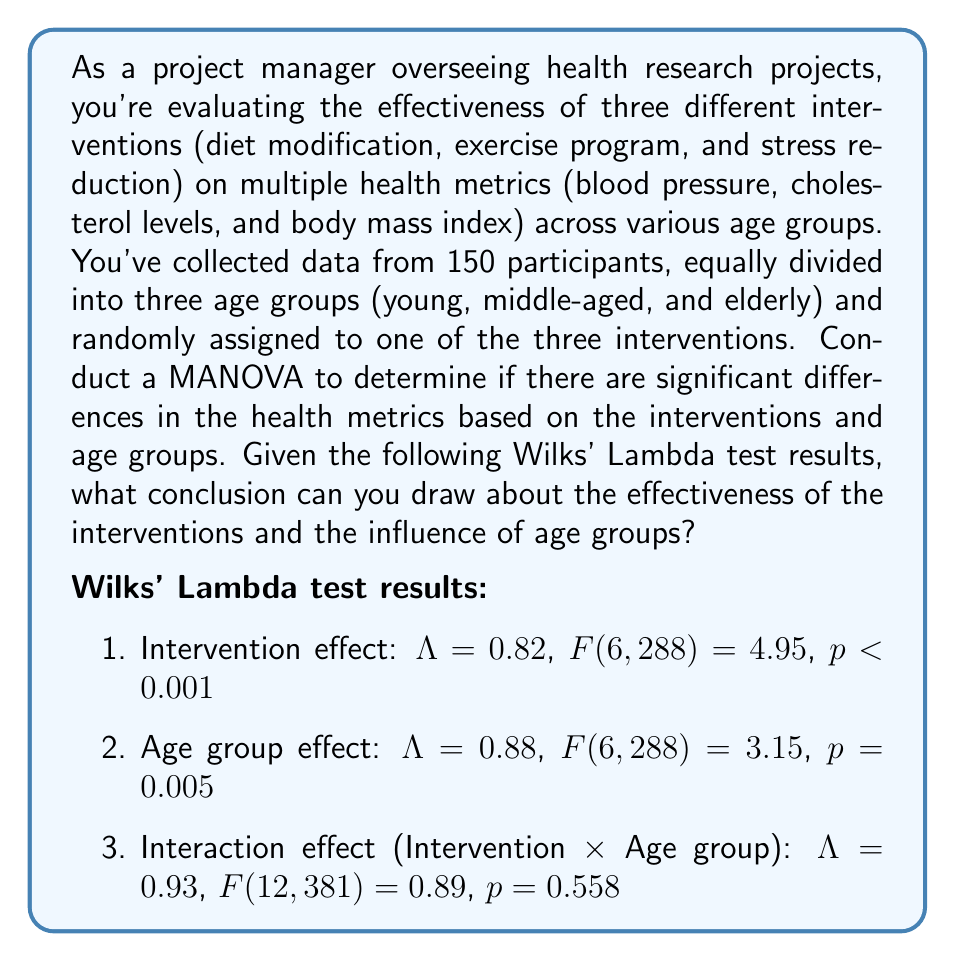Help me with this question. To interpret the MANOVA results and draw conclusions about the effectiveness of the interventions and the influence of age groups, we need to examine the Wilks' Lambda test results for each effect:

1. Intervention effect:
   - Wilks' Lambda ($\Lambda$) = 0.82
   - $F(6, 288) = 4.95$
   - $p < 0.001$

   The small p-value ($p < 0.001$) indicates strong evidence against the null hypothesis, which suggests that there are significant differences in the health metrics based on the interventions.

2. Age group effect:
   - Wilks' Lambda ($\Lambda$) = 0.88
   - $F(6, 288) = 3.15$
   - $p = 0.005$

   The p-value is less than the conventional significance level of 0.05, indicating that there are significant differences in the health metrics across age groups.

3. Interaction effect (Intervention × Age group):
   - Wilks' Lambda ($\Lambda$) = 0.93
   - $F(12, 381) = 0.89$
   - $p = 0.558$

   The large p-value ($p > 0.05$) suggests that there is no significant interaction effect between the interventions and age groups on the health metrics.

Interpretation:
1. The significant intervention effect ($p < 0.001$) indicates that the three interventions (diet modification, exercise program, and stress reduction) have different impacts on the combined health metrics (blood pressure, cholesterol levels, and body mass index).

2. The significant age group effect ($p = 0.005$) suggests that the health metrics differ across the three age groups (young, middle-aged, and elderly).

3. The non-significant interaction effect ($p = 0.558$) implies that the impact of the interventions on health metrics does not significantly vary across age groups.
Answer: Based on the MANOVA results, we can conclude that both the interventions and age groups have significant effects on the health metrics (blood pressure, cholesterol levels, and body mass index). The interventions show different levels of effectiveness in improving these health metrics, and the health metrics also vary significantly across age groups. However, the effectiveness of the interventions does not significantly depend on the age group, as there is no significant interaction effect between interventions and age groups. 